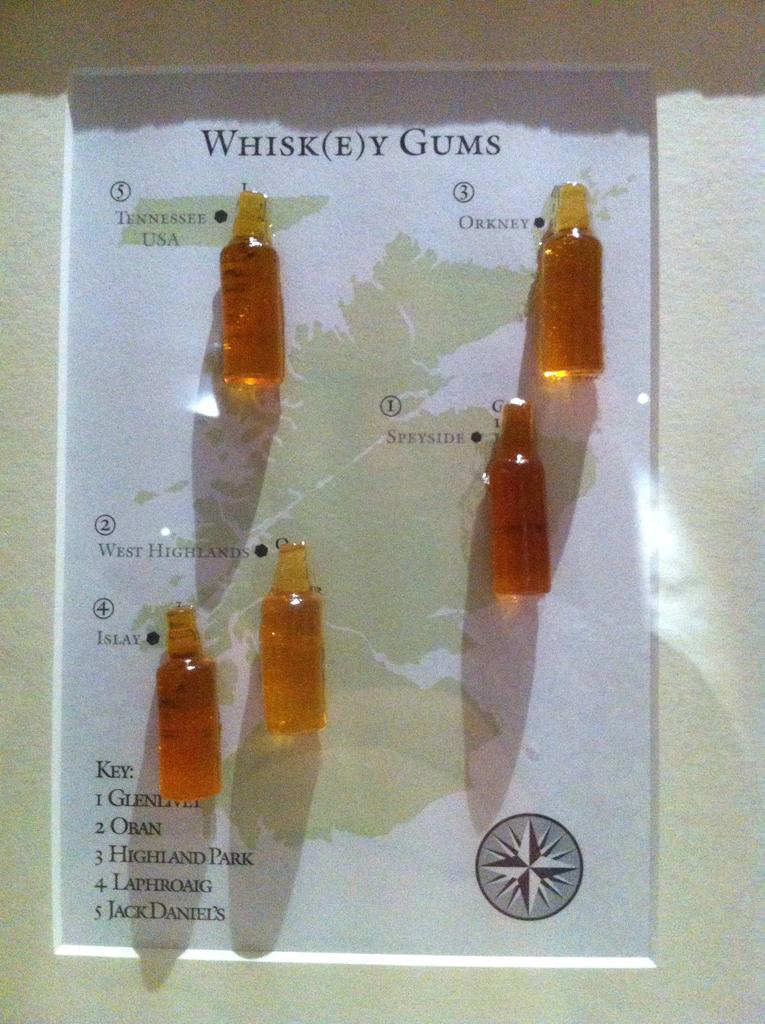What type of gum is this?
Offer a terse response. Whiskey. What is number five on the key?
Make the answer very short. Jack daniel's. 